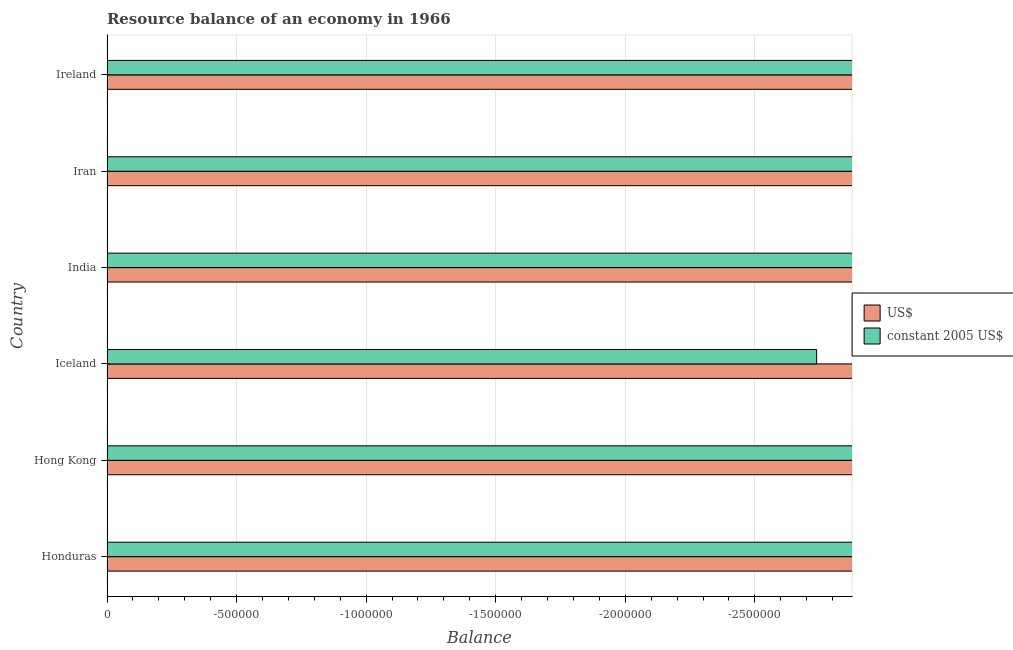Are the number of bars per tick equal to the number of legend labels?
Offer a terse response. No. How many bars are there on the 4th tick from the top?
Your answer should be very brief. 0. What is the label of the 6th group of bars from the top?
Your answer should be very brief. Honduras. In how many cases, is the number of bars for a given country not equal to the number of legend labels?
Provide a short and direct response. 6. What is the difference between the resource balance in constant us$ in Honduras and the resource balance in us$ in Hong Kong?
Provide a short and direct response. 0. In how many countries, is the resource balance in us$ greater than -2800000 units?
Offer a very short reply. 0. Are all the bars in the graph horizontal?
Make the answer very short. Yes. How many countries are there in the graph?
Give a very brief answer. 6. What is the difference between two consecutive major ticks on the X-axis?
Your response must be concise. 5.00e+05. Are the values on the major ticks of X-axis written in scientific E-notation?
Provide a short and direct response. No. Does the graph contain any zero values?
Provide a succinct answer. Yes. Does the graph contain grids?
Offer a terse response. Yes. How many legend labels are there?
Your answer should be very brief. 2. How are the legend labels stacked?
Make the answer very short. Vertical. What is the title of the graph?
Keep it short and to the point. Resource balance of an economy in 1966. What is the label or title of the X-axis?
Offer a very short reply. Balance. What is the label or title of the Y-axis?
Provide a succinct answer. Country. What is the Balance in US$ in Honduras?
Your response must be concise. 0. What is the Balance of US$ in Iceland?
Provide a succinct answer. 0. What is the Balance in constant 2005 US$ in Iceland?
Provide a short and direct response. 0. What is the Balance in US$ in India?
Give a very brief answer. 0. What is the Balance of constant 2005 US$ in India?
Ensure brevity in your answer.  0. What is the Balance of US$ in Iran?
Provide a succinct answer. 0. What is the average Balance of constant 2005 US$ per country?
Your answer should be very brief. 0. 